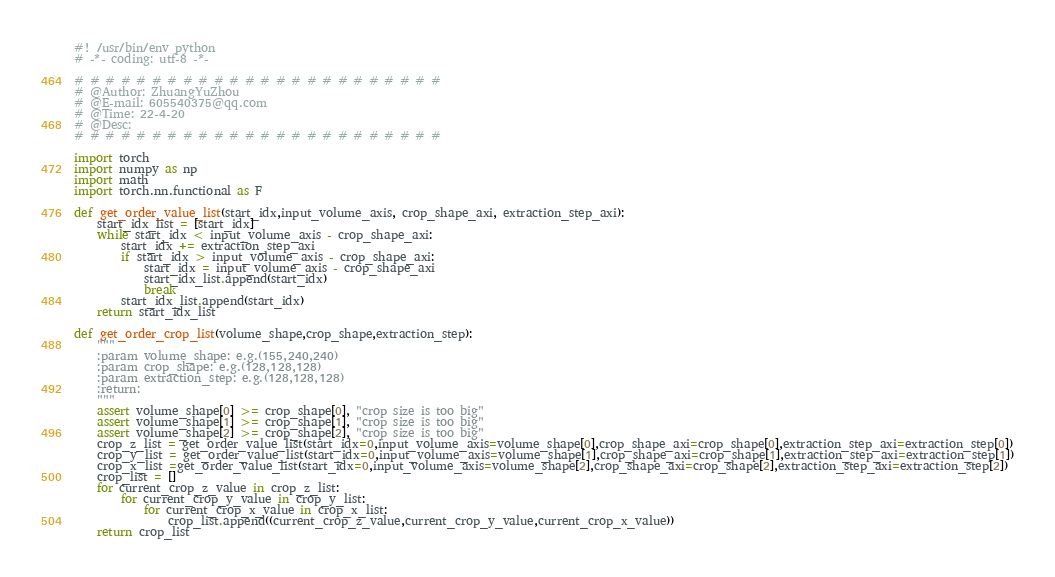<code> <loc_0><loc_0><loc_500><loc_500><_Python_>#! /usr/bin/env python
# -*- coding: utf-8 -*-

# # # # # # # # # # # # # # # # # # # # # # # # 
# @Author: ZhuangYuZhou
# @E-mail: 605540375@qq.com
# @Time: 22-4-20
# @Desc:
# # # # # # # # # # # # # # # # # # # # # # # #

import torch
import numpy as np
import math
import torch.nn.functional as F

def get_order_value_list(start_idx,input_volume_axis, crop_shape_axi, extraction_step_axi):
    start_idx_list = [start_idx]
    while start_idx < input_volume_axis - crop_shape_axi:
        start_idx += extraction_step_axi
        if start_idx > input_volume_axis - crop_shape_axi:
            start_idx = input_volume_axis - crop_shape_axi
            start_idx_list.append(start_idx)
            break
        start_idx_list.append(start_idx)
    return start_idx_list

def get_order_crop_list(volume_shape,crop_shape,extraction_step):
    """
    :param volume_shape: e.g.(155,240,240)
    :param crop_shape: e.g.(128,128,128)
    :param extraction_step: e.g.(128,128,128)
    :return:
    """
    assert volume_shape[0] >= crop_shape[0], "crop size is too big"
    assert volume_shape[1] >= crop_shape[1], "crop size is too big"
    assert volume_shape[2] >= crop_shape[2], "crop size is too big"
    crop_z_list = get_order_value_list(start_idx=0,input_volume_axis=volume_shape[0],crop_shape_axi=crop_shape[0],extraction_step_axi=extraction_step[0])
    crop_y_list = get_order_value_list(start_idx=0,input_volume_axis=volume_shape[1],crop_shape_axi=crop_shape[1],extraction_step_axi=extraction_step[1])
    crop_x_list =get_order_value_list(start_idx=0,input_volume_axis=volume_shape[2],crop_shape_axi=crop_shape[2],extraction_step_axi=extraction_step[2])
    crop_list = []
    for current_crop_z_value in crop_z_list:
        for current_crop_y_value in crop_y_list:
            for current_crop_x_value in crop_x_list:
                crop_list.append((current_crop_z_value,current_crop_y_value,current_crop_x_value))
    return crop_list



</code> 